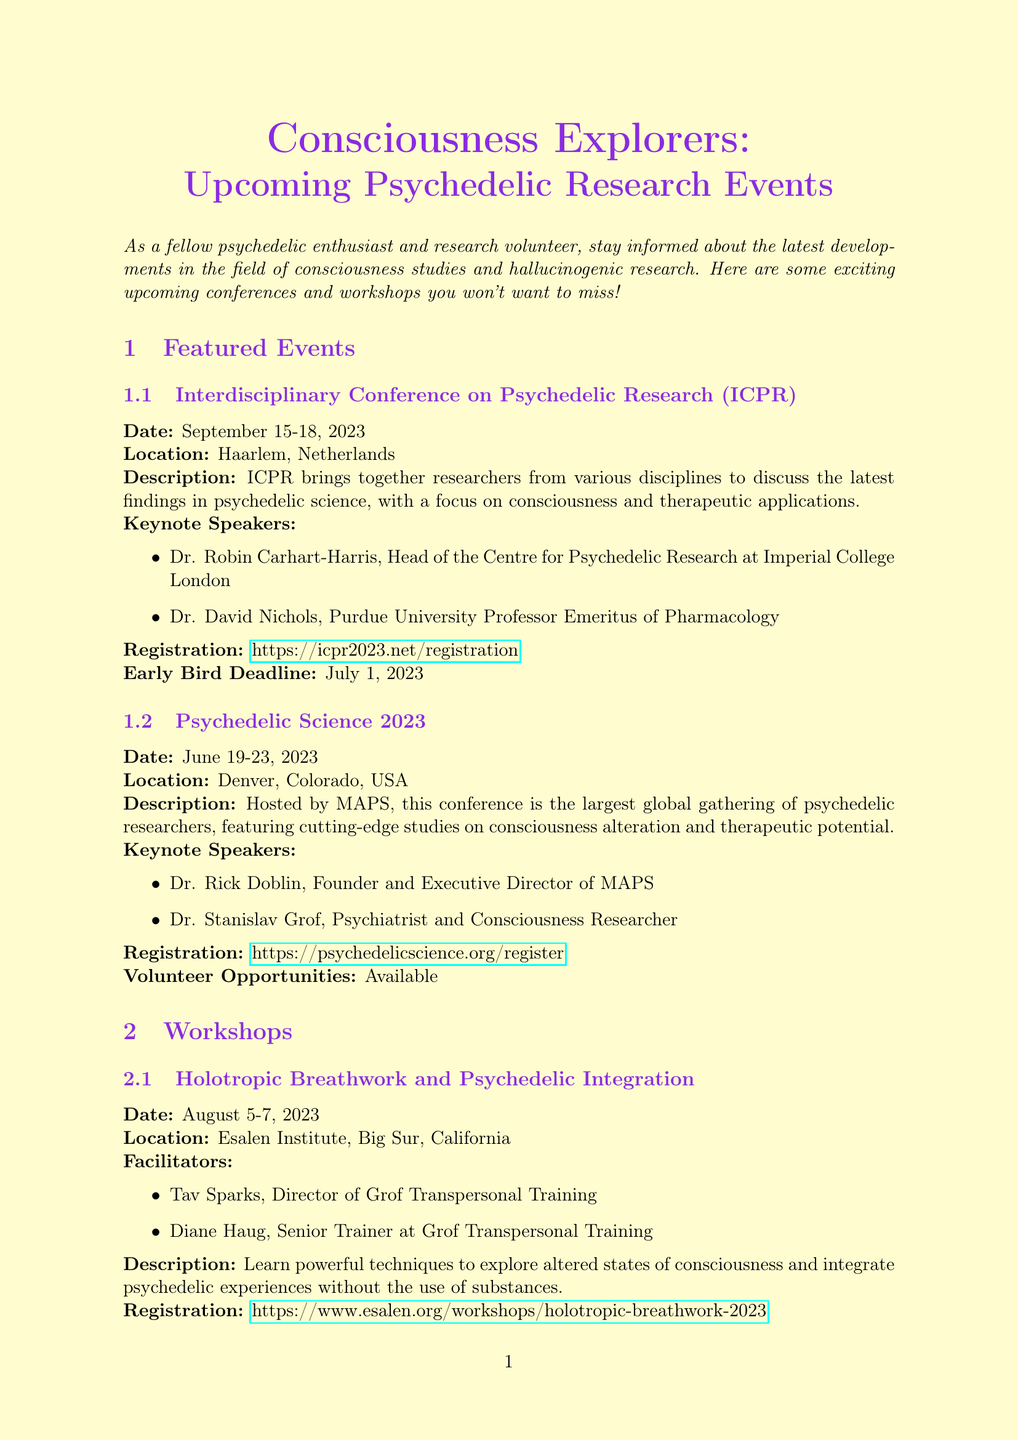What is the date of the ICPR conference? The date of the ICPR conference is given in the document, which is September 15-18, 2023.
Answer: September 15-18, 2023 Who is a keynote speaker at Psychedelic Science 2023? The document lists the keynote speakers for Psychedelic Science 2023, including Dr. Rick Doblin.
Answer: Dr. Rick Doblin What is the location of the Holotropic Breathwork and Psychedelic Integration workshop? The location for the Holotropic Breathwork and Psychedelic Integration workshop is stated in the document as Big Sur, California.
Answer: Big Sur, California What is the early bird registration deadline for ICPR? The early bird registration deadline is provided in the document, which is July 1, 2023.
Answer: July 1, 2023 Are there volunteer opportunities available at Psychedelic Science 2023? The document explicitly mentions whether volunteer opportunities are available for this event.
Answer: Available What is the main focus of the ICPR conference? The main focus of the ICPR conference is detailed in the description, emphasizing psychedelic science and therapeutic applications.
Answer: Consciousness and therapeutic applications What prerequisites are recommended for the Psychedelic Neuroscience Intensive workshop? The document states that a background in neuroscience or a related field is recommended as a prerequisite for this workshop.
Answer: Background in neuroscience or related field What type of resources does the Psychedelic Research Bulletin provide? The document summarizes the resources offered by the Psychedelic Research Bulletin, specifically mentioning recent publications.
Answer: Recent publications and ongoing studies 